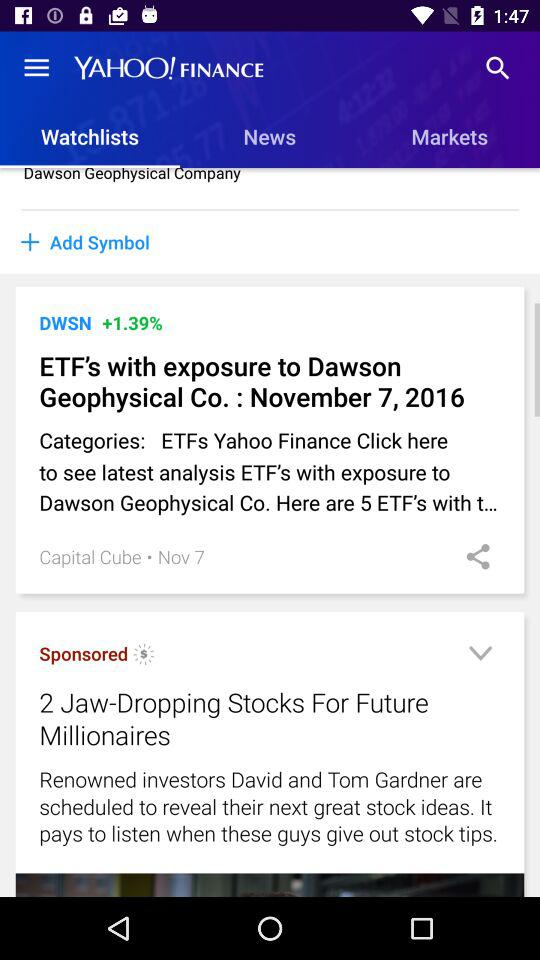Which option is selected in "YAHOO! FINANCE"? The selected option is "Watchlists". 